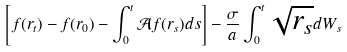<formula> <loc_0><loc_0><loc_500><loc_500>\left [ f ( r _ { t } ) - f ( r _ { 0 } ) - \int _ { 0 } ^ { t } \mathcal { A } f ( r _ { s } ) d s \right ] - \frac { \sigma } { a } \int _ { 0 } ^ { t } \sqrt { r _ { s } } d W _ { s }</formula> 